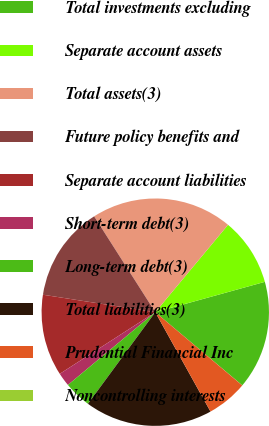Convert chart to OTSL. <chart><loc_0><loc_0><loc_500><loc_500><pie_chart><fcel>Total investments excluding<fcel>Separate account assets<fcel>Total assets(3)<fcel>Future policy benefits and<fcel>Separate account liabilities<fcel>Short-term debt(3)<fcel>Long-term debt(3)<fcel>Total liabilities(3)<fcel>Prudential Financial Inc<fcel>Noncontrolling interests<nl><fcel>15.43%<fcel>9.65%<fcel>20.09%<fcel>13.51%<fcel>11.58%<fcel>1.93%<fcel>3.86%<fcel>18.16%<fcel>5.79%<fcel>0.01%<nl></chart> 